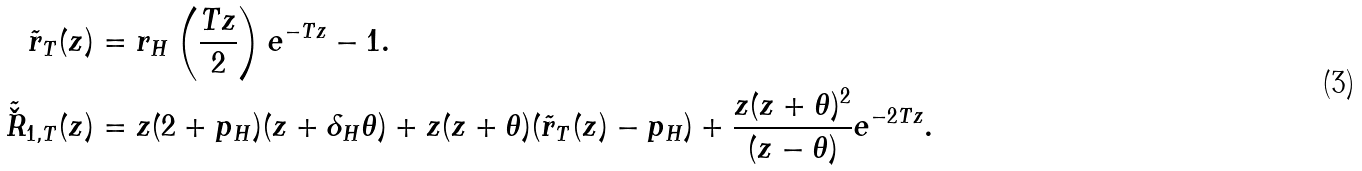Convert formula to latex. <formula><loc_0><loc_0><loc_500><loc_500>\tilde { r } _ { T } ( z ) & = r _ { H } \left ( \frac { T z } { 2 } \right ) e ^ { - T z } - 1 . \\ \tilde { \check { R } } _ { 1 , T } ( z ) & = z ( 2 + p _ { H } ) ( z + \delta _ { H } \theta ) + z ( z + \theta ) ( \tilde { r } _ { T } ( z ) - p _ { H } ) + \frac { z ( z + \theta ) ^ { 2 } } { ( z - \theta ) } e ^ { - 2 T z } .</formula> 